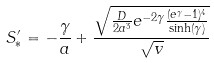<formula> <loc_0><loc_0><loc_500><loc_500>S ^ { \prime } _ { * } = - \frac { \gamma } { a } + \frac { \sqrt { \frac { D } { 2 a ^ { 3 } } e ^ { - 2 \gamma } \frac { ( e ^ { \gamma } - 1 ) ^ { 4 } } { \sinh ( \gamma ) } } } { \sqrt { v } }</formula> 